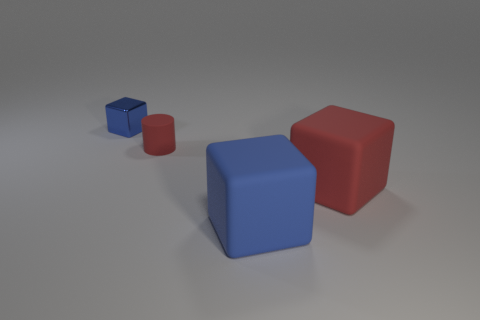Subtract all small metallic blocks. How many blocks are left? 2 Subtract all blue blocks. How many blocks are left? 1 Add 1 brown matte cubes. How many objects exist? 5 Subtract all yellow cylinders. How many red blocks are left? 1 Subtract all green cylinders. Subtract all gray cubes. How many cylinders are left? 1 Subtract all brown rubber balls. Subtract all rubber objects. How many objects are left? 1 Add 1 matte cubes. How many matte cubes are left? 3 Add 2 tiny green cylinders. How many tiny green cylinders exist? 2 Subtract 0 gray cubes. How many objects are left? 4 Subtract all blocks. How many objects are left? 1 